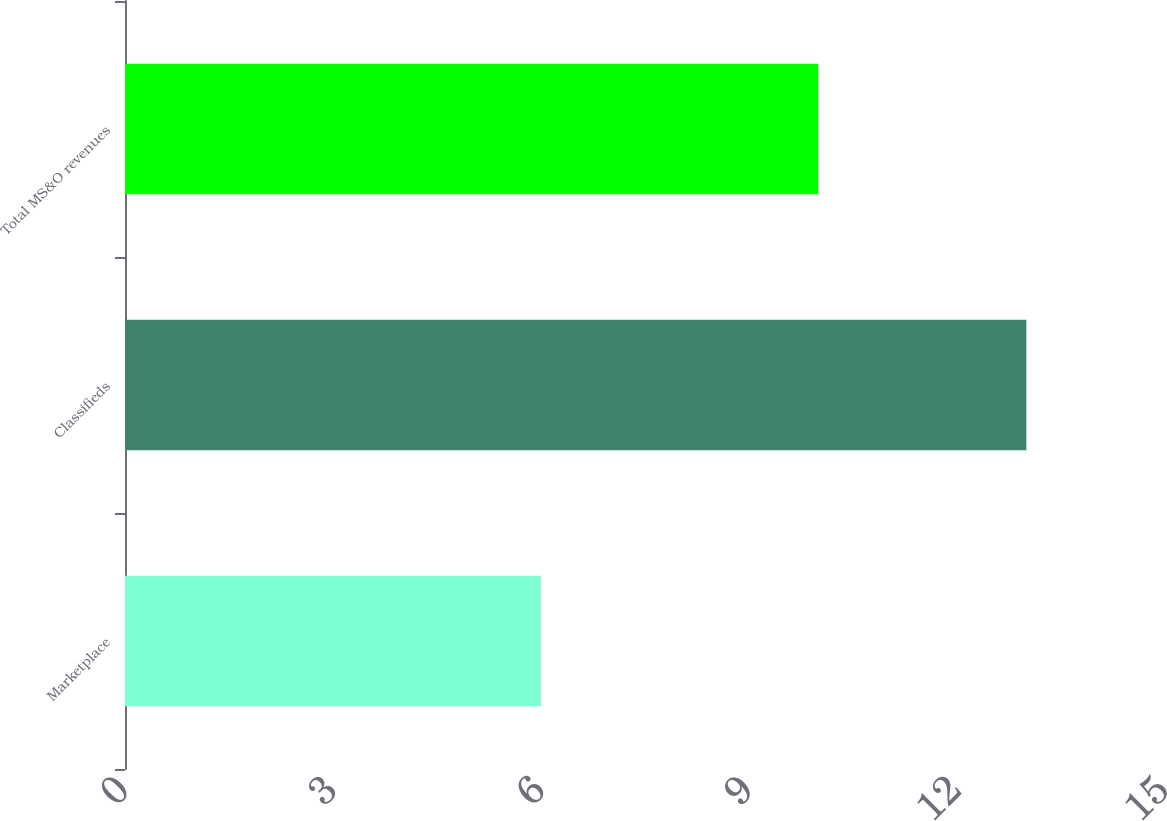Convert chart. <chart><loc_0><loc_0><loc_500><loc_500><bar_chart><fcel>Marketplace<fcel>Classifieds<fcel>Total MS&O revenues<nl><fcel>6<fcel>13<fcel>10<nl></chart> 